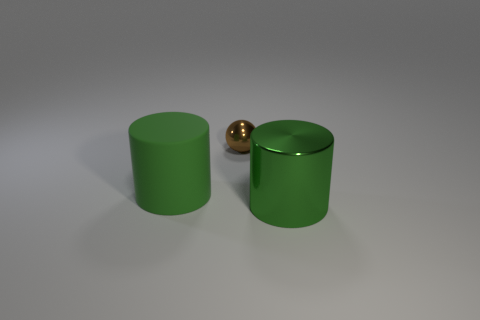Add 1 tiny brown shiny spheres. How many objects exist? 4 Subtract all cylinders. How many objects are left? 1 Subtract all tiny objects. Subtract all tiny green cylinders. How many objects are left? 2 Add 1 large matte objects. How many large matte objects are left? 2 Add 2 gray metallic cubes. How many gray metallic cubes exist? 2 Subtract 0 gray blocks. How many objects are left? 3 